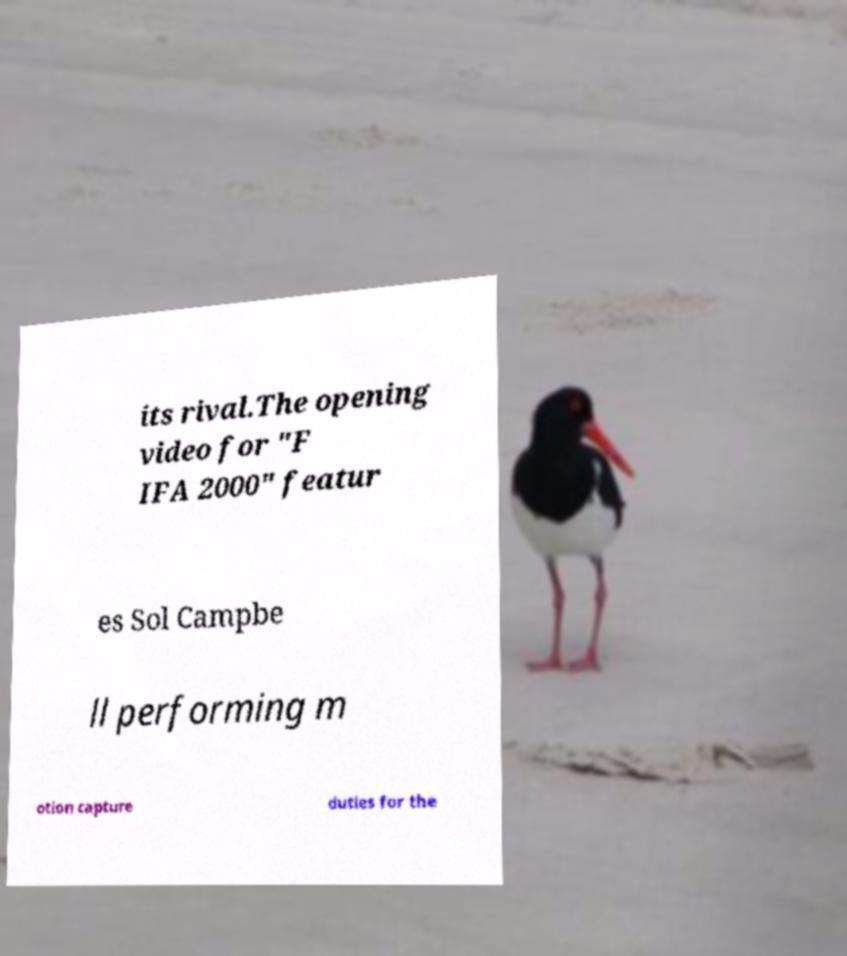What messages or text are displayed in this image? I need them in a readable, typed format. its rival.The opening video for "F IFA 2000" featur es Sol Campbe ll performing m otion capture duties for the 